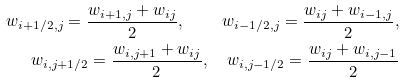Convert formula to latex. <formula><loc_0><loc_0><loc_500><loc_500>w _ { i + 1 / 2 , j } = \frac { w _ { i + 1 , j } + w _ { i j } } 2 , \quad w _ { i - 1 / 2 , j } = \frac { w _ { i j } + w _ { i - 1 , j } } 2 , \\ w _ { i , j + 1 / 2 } = \frac { w _ { i , j + 1 } + w _ { i j } } 2 , \quad w _ { i , j - 1 / 2 } = \frac { w _ { i j } + w _ { i , j - 1 } } 2</formula> 